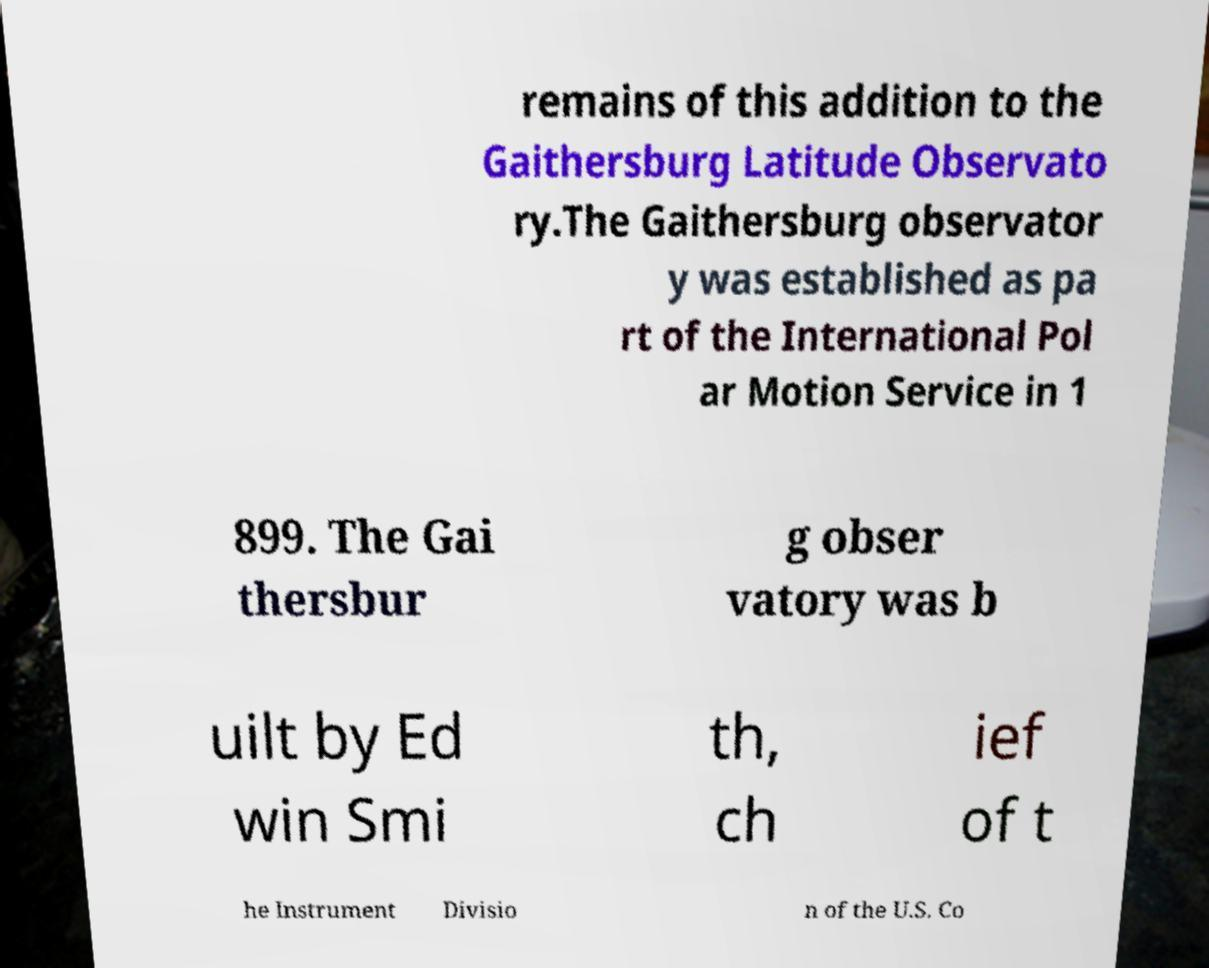Could you assist in decoding the text presented in this image and type it out clearly? remains of this addition to the Gaithersburg Latitude Observato ry.The Gaithersburg observator y was established as pa rt of the International Pol ar Motion Service in 1 899. The Gai thersbur g obser vatory was b uilt by Ed win Smi th, ch ief of t he Instrument Divisio n of the U.S. Co 